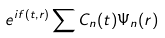<formula> <loc_0><loc_0><loc_500><loc_500>e ^ { i f ( t , { r } ) } \sum C _ { n } ( t ) \Psi _ { n } ( { r } )</formula> 